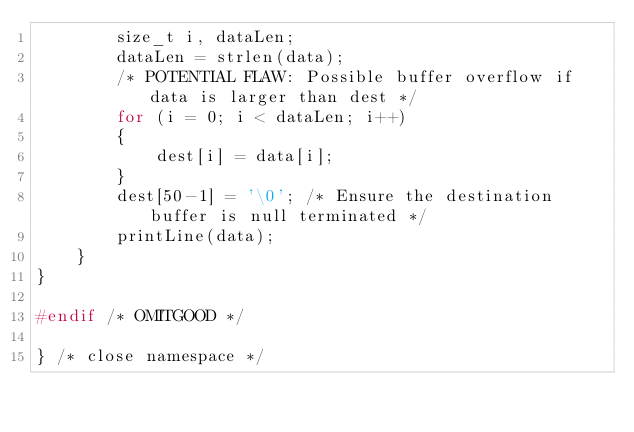<code> <loc_0><loc_0><loc_500><loc_500><_C++_>        size_t i, dataLen;
        dataLen = strlen(data);
        /* POTENTIAL FLAW: Possible buffer overflow if data is larger than dest */
        for (i = 0; i < dataLen; i++)
        {
            dest[i] = data[i];
        }
        dest[50-1] = '\0'; /* Ensure the destination buffer is null terminated */
        printLine(data);
    }
}

#endif /* OMITGOOD */

} /* close namespace */
</code> 